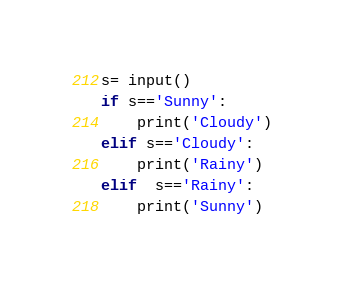Convert code to text. <code><loc_0><loc_0><loc_500><loc_500><_Python_>s= input()
if s=='Sunny':
    print('Cloudy')
elif s=='Cloudy':
    print('Rainy')
elif  s=='Rainy':
    print('Sunny')</code> 